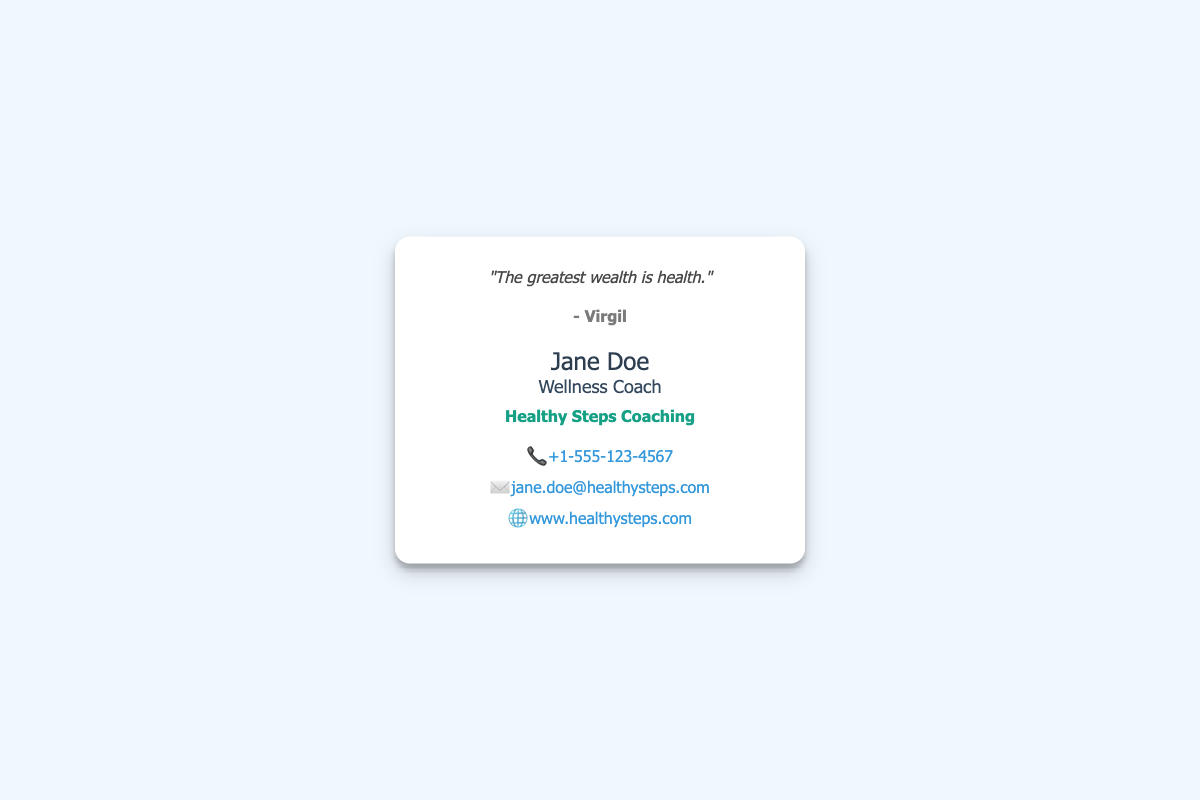what is the name of the wellness coach? The name of the wellness coach is prominently displayed at the bottom of the card.
Answer: Jane Doe what is the quote on the card? The quote is found at the top of the card.
Answer: "The greatest wealth is health." who is the author of the quote? The author of the quote is indicated below the quote itself.
Answer: Virgil what organization is Jane Doe associated with? The organization name is listed beneath the title on the card.
Answer: Healthy Steps Coaching what is Jane Doe's phone number? The phone number is included in the contact information section.
Answer: +1-555-123-4567 what is Jane Doe's email address? The email address is provided in the contact information area of the card.
Answer: jane.doe@healthysteps.com what type of document is this? The structure and information presented suggest a particular purpose.
Answer: Business card how can you contact Jane Doe? The card lists specific contact methods available for reaching Jane.
Answer: Phone, Email, Website what is Jane Doe's title? The title is mentioned prominently beneath her name.
Answer: Wellness Coach 